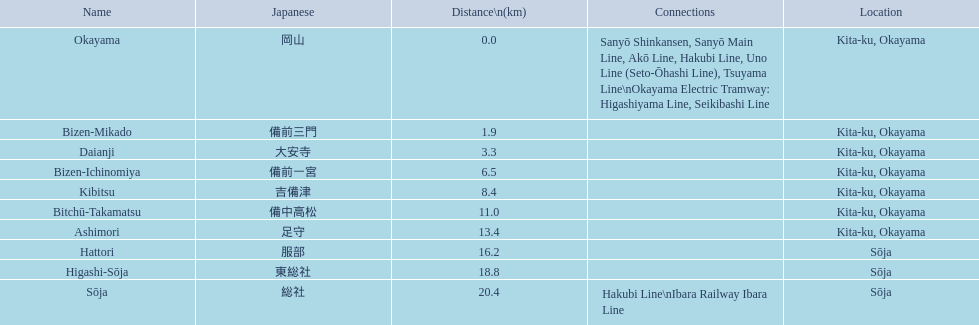What are all of the train names? Okayama, Bizen-Mikado, Daianji, Bizen-Ichinomiya, Kibitsu, Bitchū-Takamatsu, Ashimori, Hattori, Higashi-Sōja, Sōja. What is the distance for each? 0.0, 1.9, 3.3, 6.5, 8.4, 11.0, 13.4, 16.2, 18.8, 20.4. And which train's distance is between 1 and 2 km? Bizen-Mikado. 